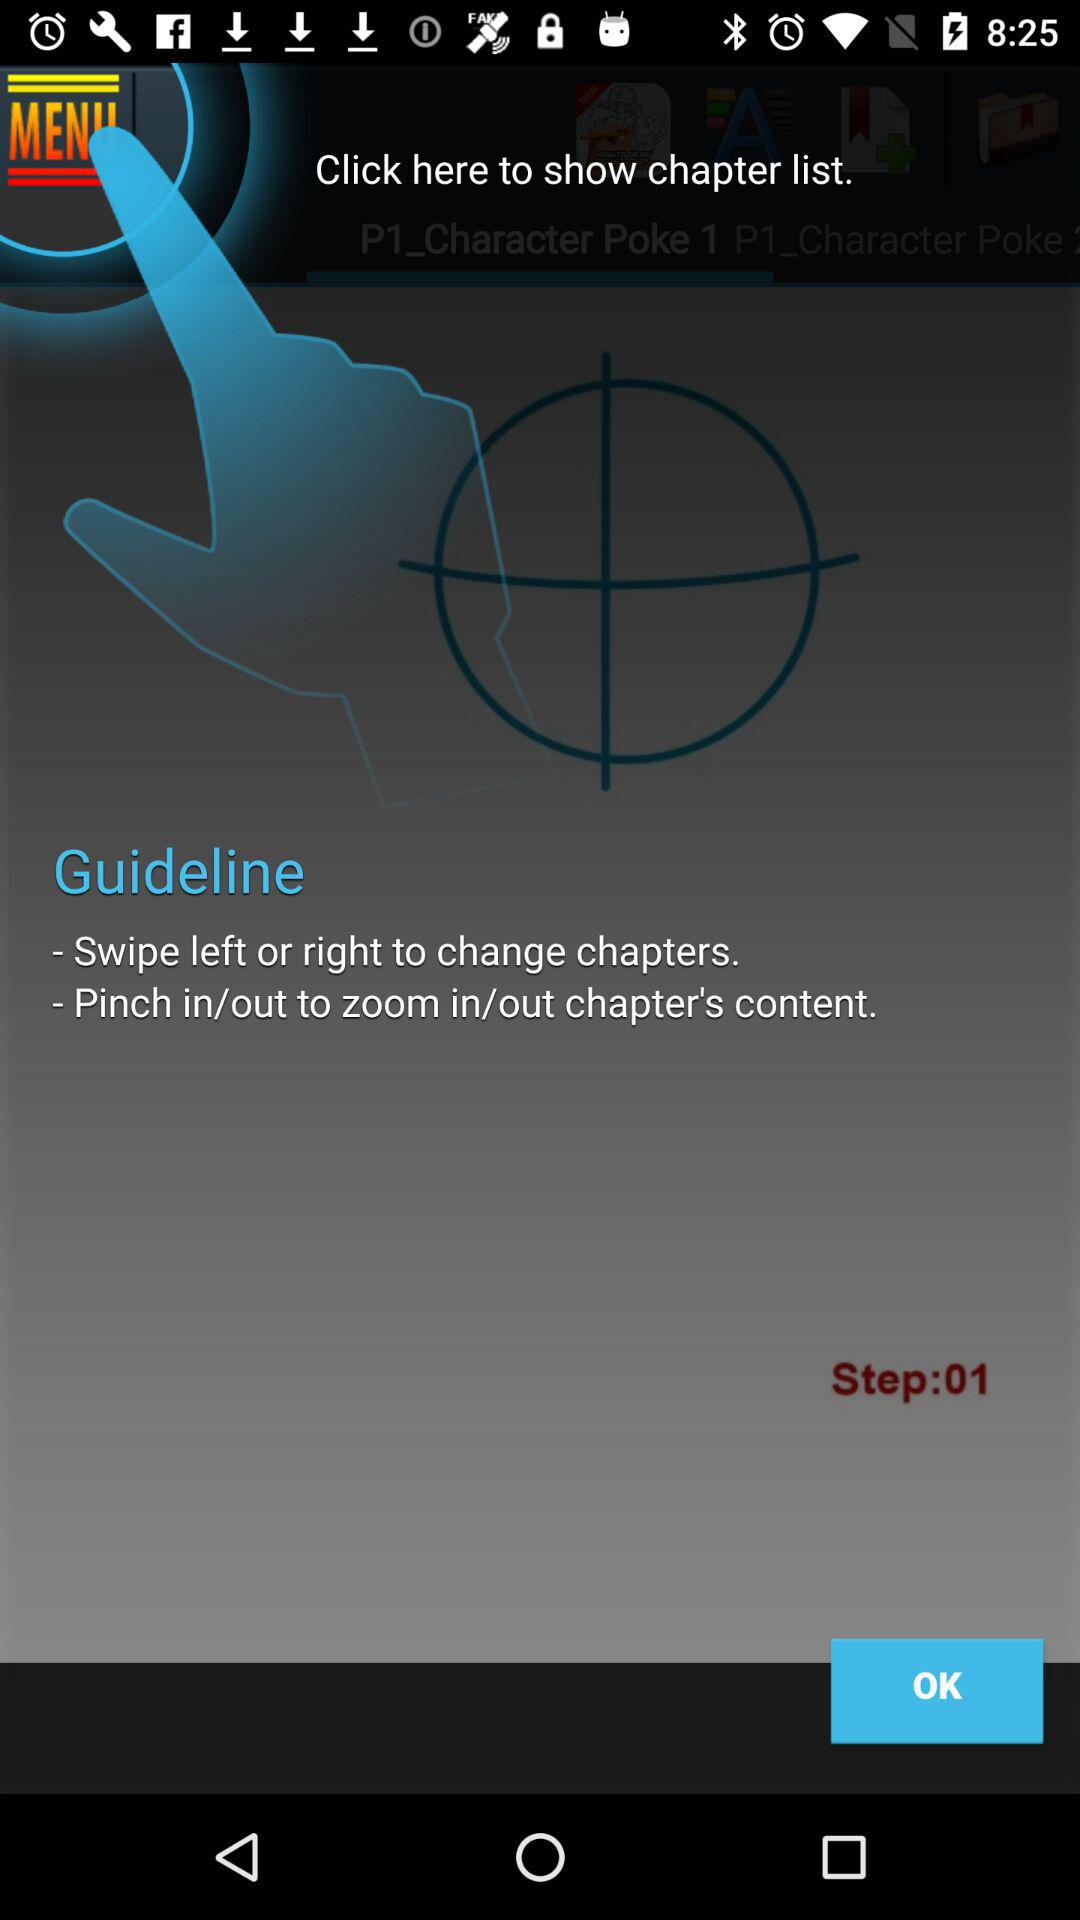What step are we at currently? You are currently at step 1. 